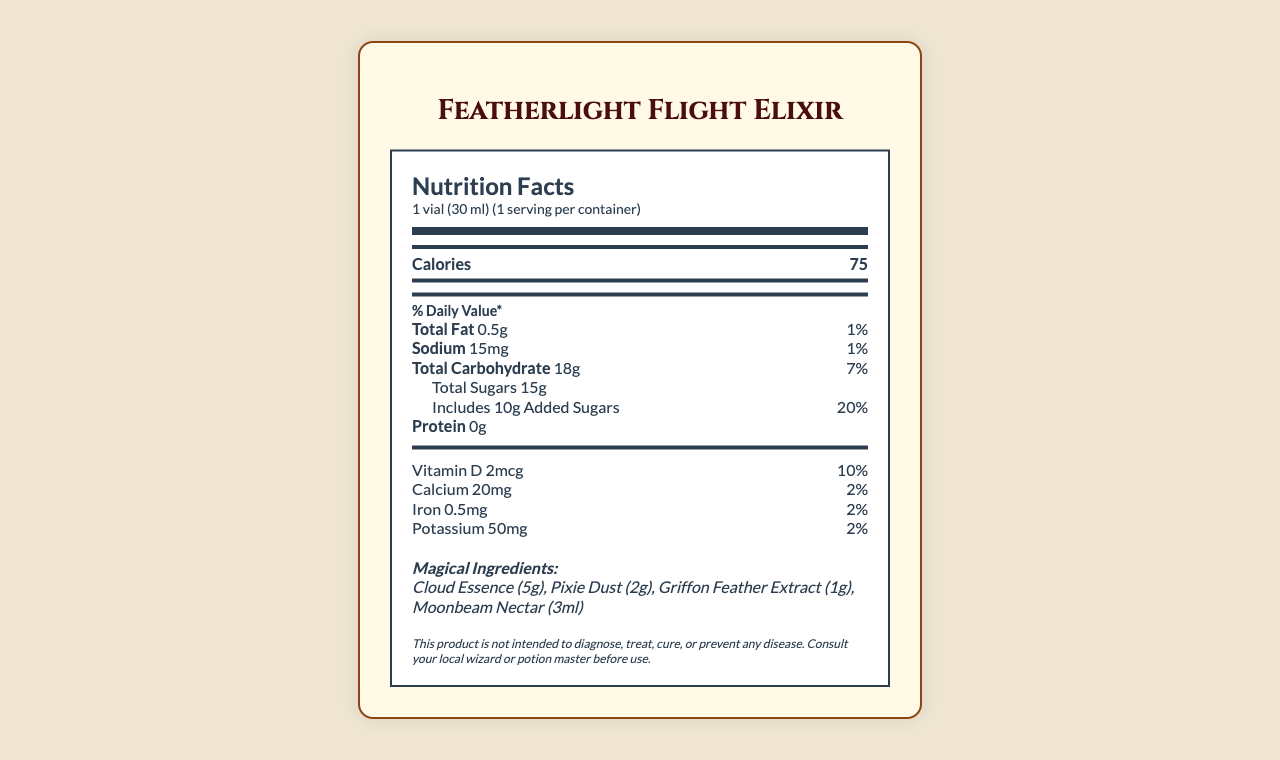What is the calorie content per serving of the Featherlight Flight Elixir? The document lists calories as 75 per serving directly under the serving size and servings per container information.
Answer: 75 How much sodium does one vial of Featherlight Flight Elixir contain? The sodium content is listed as 15mg in the document, along with a daily value percentage of 1%.
Answer: 15mg What are the magical ingredients in the Featherlight Flight Elixir? The document specifies magical ingredients as Cloud Essence (5g), Pixie Dust (2g), Griffon Feather Extract (1g), and Moonbeam Nectar (3ml).
Answer: Cloud Essence, Pixie Dust, Griffon Feather Extract, Moonbeam Nectar How long does the effect of the Featherlight Flight Elixir last? The directions section of the document states that the effects last up to 30 minutes.
Answer: Up to 30 minutes How much added sugar is in the Featherlight Flight Elixir? The document specifies that the elixir contains 10g of added sugars.
Answer: 10g How should the Featherlight Flight Elixir be stored? The storage instructions in the document advise storing the elixir in a cool, dry place away from direct sunlight.
Answer: Store in a cool, dry place away from direct sunlight What is the daily value percentage of vitamin D in the Featherlight Flight Elixir? The document lists the daily value percentage of vitamin D as 10%.
Answer: 10% What are the side effects of consuming the Featherlight Flight Elixir? The document lists the side effects as temporary weightlessness, slight dizziness, and euphoria.
Answer: Temporary weightlessness, slight dizziness, euphoria What is the serving size of the Featherlight Flight Elixir? The serving size is mentioned as 1 vial (30 ml) at the top of the nutrition facts.
Answer: 1 vial (30 ml) Which statement is true about the elixir's protein content? A. Contains 5g of protein B. Contains 2g of protein C. Contains 0g of protein The document indicates that the elixir contains 0g of protein.
Answer: C What percentage of the daily value of calcium does the elixir provide? A. 2% B. 10% C. 7% The document lists the daily value percentage of calcium as 2%.
Answer: A What should you do before consuming the Featherlight Flight Elixir? A. Shake well before use B. Keep it in the fridge C. Drink with food The directions section states to shake well before use.
Answer: A Does the Featherlight Flight Elixir contain any allergens? The document warns that the elixir contains trace amounts of nuts due to Pixie Dust processing.
Answer: Yes Summarize the main aspects of the Featherlight Flight Elixir's nutrition facts and additional information. This summary captures the main nutrients and magical ingredients, directions for use, side effects, allergens, and storage details derived from the Featherlight Flight Elixir's nutrition facts document.
Answer: The Featherlight Flight Elixir includes 75 calories per serving (1 vial, 30 ml) with low fat and sodium but has 18g of carbohydrates mainly from sugars. It provides 10% of the daily value of vitamin D and small amounts of calcium, iron, and potassium. Magical ingredients include Cloud Essence, Pixie Dust, Griffon Feather Extract, and Moonbeam Nectar. Directions include shaking well before use with effects lasting up to 30 minutes, and there are warnings about side effects and storage recommendations. When was Whimsical Wonders Potion Co. established? The document does not provide any information about the establishment date of Whimsical Wonders Potion Co.
Answer: Cannot be determined 